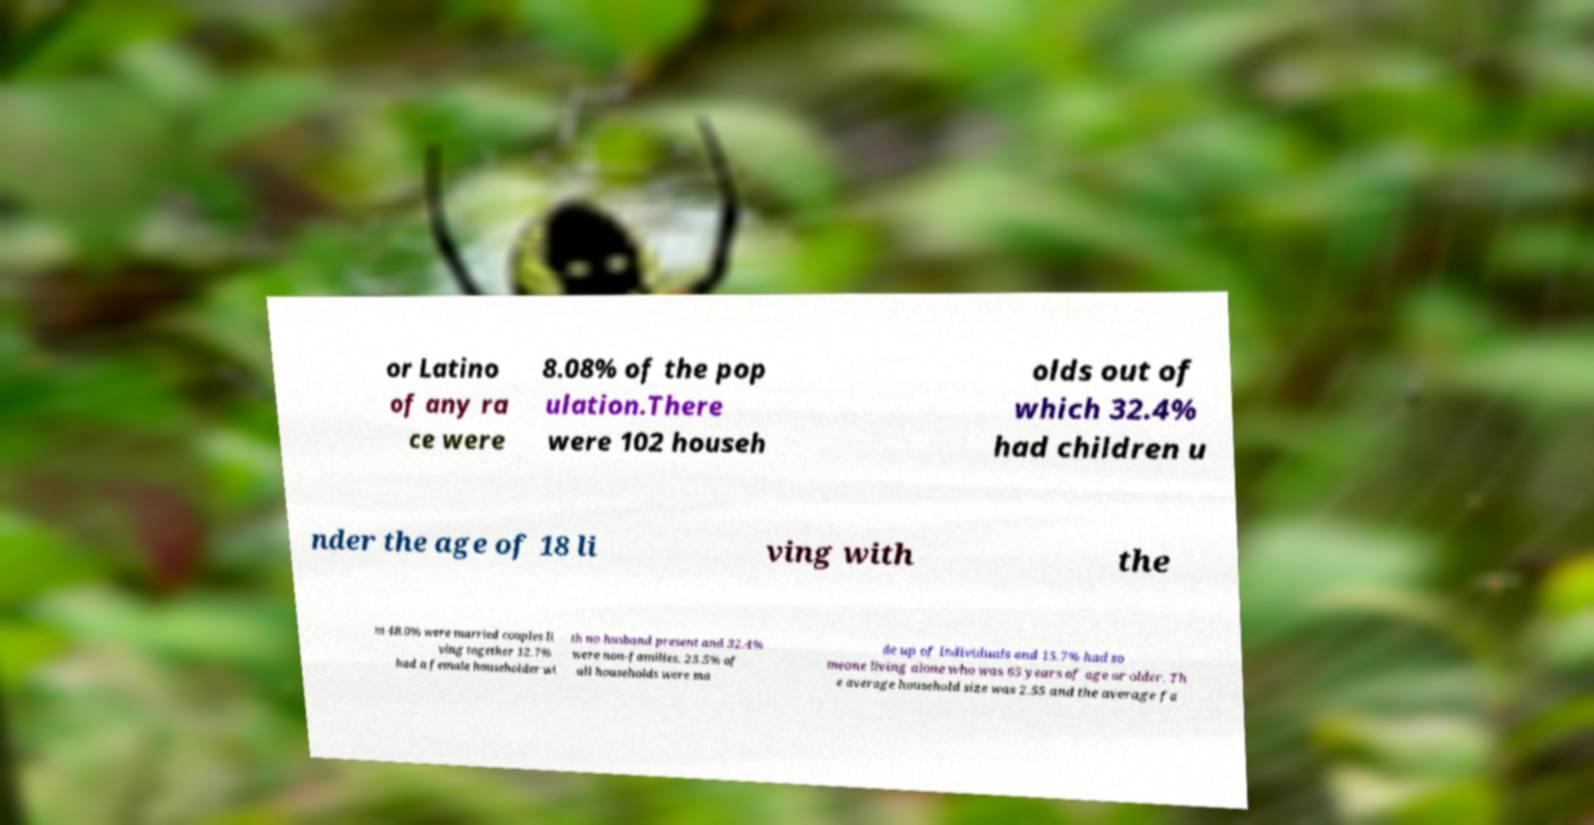Can you accurately transcribe the text from the provided image for me? or Latino of any ra ce were 8.08% of the pop ulation.There were 102 househ olds out of which 32.4% had children u nder the age of 18 li ving with the m 48.0% were married couples li ving together 12.7% had a female householder wi th no husband present and 32.4% were non-families. 23.5% of all households were ma de up of individuals and 15.7% had so meone living alone who was 65 years of age or older. Th e average household size was 2.55 and the average fa 